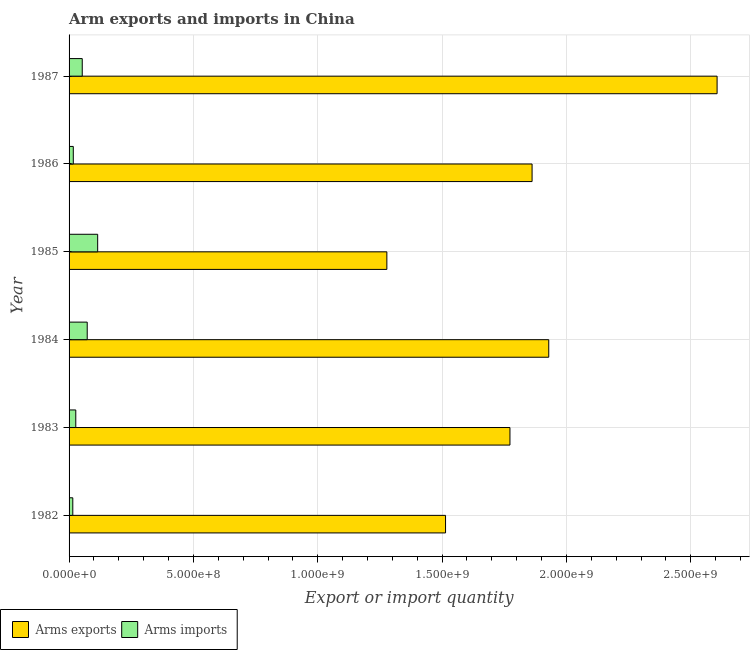Are the number of bars per tick equal to the number of legend labels?
Make the answer very short. Yes. How many bars are there on the 6th tick from the top?
Provide a short and direct response. 2. How many bars are there on the 6th tick from the bottom?
Keep it short and to the point. 2. What is the label of the 3rd group of bars from the top?
Ensure brevity in your answer.  1985. In how many cases, is the number of bars for a given year not equal to the number of legend labels?
Offer a terse response. 0. What is the arms imports in 1985?
Offer a very short reply. 1.15e+08. Across all years, what is the maximum arms imports?
Ensure brevity in your answer.  1.15e+08. Across all years, what is the minimum arms exports?
Give a very brief answer. 1.28e+09. In which year was the arms exports minimum?
Give a very brief answer. 1985. What is the total arms exports in the graph?
Offer a very short reply. 1.10e+1. What is the difference between the arms exports in 1983 and that in 1984?
Provide a succinct answer. -1.56e+08. What is the difference between the arms exports in 1987 and the arms imports in 1982?
Offer a very short reply. 2.59e+09. In the year 1986, what is the difference between the arms imports and arms exports?
Your answer should be compact. -1.84e+09. In how many years, is the arms exports greater than 1100000000 ?
Offer a terse response. 6. What is the ratio of the arms exports in 1982 to that in 1983?
Provide a short and direct response. 0.85. Is the arms exports in 1986 less than that in 1987?
Your answer should be very brief. Yes. What is the difference between the highest and the second highest arms imports?
Offer a very short reply. 4.20e+07. What is the difference between the highest and the lowest arms exports?
Your answer should be compact. 1.33e+09. In how many years, is the arms exports greater than the average arms exports taken over all years?
Ensure brevity in your answer.  3. Is the sum of the arms exports in 1984 and 1987 greater than the maximum arms imports across all years?
Your response must be concise. Yes. What does the 1st bar from the top in 1987 represents?
Make the answer very short. Arms imports. What does the 2nd bar from the bottom in 1984 represents?
Provide a succinct answer. Arms imports. How many bars are there?
Offer a terse response. 12. What is the difference between two consecutive major ticks on the X-axis?
Your answer should be compact. 5.00e+08. Where does the legend appear in the graph?
Offer a very short reply. Bottom left. How many legend labels are there?
Keep it short and to the point. 2. How are the legend labels stacked?
Offer a terse response. Horizontal. What is the title of the graph?
Your answer should be compact. Arm exports and imports in China. Does "Drinking water services" appear as one of the legend labels in the graph?
Offer a terse response. No. What is the label or title of the X-axis?
Give a very brief answer. Export or import quantity. What is the Export or import quantity of Arms exports in 1982?
Your answer should be compact. 1.51e+09. What is the Export or import quantity in Arms imports in 1982?
Provide a short and direct response. 1.50e+07. What is the Export or import quantity in Arms exports in 1983?
Your answer should be compact. 1.77e+09. What is the Export or import quantity in Arms imports in 1983?
Ensure brevity in your answer.  2.70e+07. What is the Export or import quantity in Arms exports in 1984?
Offer a terse response. 1.93e+09. What is the Export or import quantity of Arms imports in 1984?
Your response must be concise. 7.30e+07. What is the Export or import quantity in Arms exports in 1985?
Your answer should be compact. 1.28e+09. What is the Export or import quantity of Arms imports in 1985?
Provide a succinct answer. 1.15e+08. What is the Export or import quantity of Arms exports in 1986?
Offer a very short reply. 1.86e+09. What is the Export or import quantity of Arms imports in 1986?
Offer a very short reply. 1.70e+07. What is the Export or import quantity of Arms exports in 1987?
Provide a short and direct response. 2.61e+09. What is the Export or import quantity of Arms imports in 1987?
Your answer should be compact. 5.30e+07. Across all years, what is the maximum Export or import quantity of Arms exports?
Make the answer very short. 2.61e+09. Across all years, what is the maximum Export or import quantity in Arms imports?
Keep it short and to the point. 1.15e+08. Across all years, what is the minimum Export or import quantity in Arms exports?
Ensure brevity in your answer.  1.28e+09. Across all years, what is the minimum Export or import quantity of Arms imports?
Your answer should be compact. 1.50e+07. What is the total Export or import quantity in Arms exports in the graph?
Your response must be concise. 1.10e+1. What is the total Export or import quantity in Arms imports in the graph?
Offer a very short reply. 3.00e+08. What is the difference between the Export or import quantity of Arms exports in 1982 and that in 1983?
Your answer should be very brief. -2.59e+08. What is the difference between the Export or import quantity in Arms imports in 1982 and that in 1983?
Give a very brief answer. -1.20e+07. What is the difference between the Export or import quantity of Arms exports in 1982 and that in 1984?
Offer a terse response. -4.15e+08. What is the difference between the Export or import quantity in Arms imports in 1982 and that in 1984?
Offer a terse response. -5.80e+07. What is the difference between the Export or import quantity of Arms exports in 1982 and that in 1985?
Your answer should be compact. 2.36e+08. What is the difference between the Export or import quantity in Arms imports in 1982 and that in 1985?
Keep it short and to the point. -1.00e+08. What is the difference between the Export or import quantity in Arms exports in 1982 and that in 1986?
Your response must be concise. -3.48e+08. What is the difference between the Export or import quantity in Arms exports in 1982 and that in 1987?
Keep it short and to the point. -1.09e+09. What is the difference between the Export or import quantity of Arms imports in 1982 and that in 1987?
Give a very brief answer. -3.80e+07. What is the difference between the Export or import quantity of Arms exports in 1983 and that in 1984?
Ensure brevity in your answer.  -1.56e+08. What is the difference between the Export or import quantity in Arms imports in 1983 and that in 1984?
Offer a very short reply. -4.60e+07. What is the difference between the Export or import quantity in Arms exports in 1983 and that in 1985?
Provide a short and direct response. 4.95e+08. What is the difference between the Export or import quantity in Arms imports in 1983 and that in 1985?
Provide a short and direct response. -8.80e+07. What is the difference between the Export or import quantity of Arms exports in 1983 and that in 1986?
Offer a terse response. -8.90e+07. What is the difference between the Export or import quantity of Arms exports in 1983 and that in 1987?
Keep it short and to the point. -8.33e+08. What is the difference between the Export or import quantity in Arms imports in 1983 and that in 1987?
Your answer should be compact. -2.60e+07. What is the difference between the Export or import quantity in Arms exports in 1984 and that in 1985?
Your answer should be very brief. 6.51e+08. What is the difference between the Export or import quantity of Arms imports in 1984 and that in 1985?
Keep it short and to the point. -4.20e+07. What is the difference between the Export or import quantity of Arms exports in 1984 and that in 1986?
Offer a terse response. 6.70e+07. What is the difference between the Export or import quantity in Arms imports in 1984 and that in 1986?
Your answer should be compact. 5.60e+07. What is the difference between the Export or import quantity of Arms exports in 1984 and that in 1987?
Your answer should be very brief. -6.77e+08. What is the difference between the Export or import quantity in Arms imports in 1984 and that in 1987?
Keep it short and to the point. 2.00e+07. What is the difference between the Export or import quantity in Arms exports in 1985 and that in 1986?
Ensure brevity in your answer.  -5.84e+08. What is the difference between the Export or import quantity of Arms imports in 1985 and that in 1986?
Ensure brevity in your answer.  9.80e+07. What is the difference between the Export or import quantity of Arms exports in 1985 and that in 1987?
Offer a terse response. -1.33e+09. What is the difference between the Export or import quantity in Arms imports in 1985 and that in 1987?
Provide a succinct answer. 6.20e+07. What is the difference between the Export or import quantity in Arms exports in 1986 and that in 1987?
Offer a terse response. -7.44e+08. What is the difference between the Export or import quantity of Arms imports in 1986 and that in 1987?
Provide a short and direct response. -3.60e+07. What is the difference between the Export or import quantity of Arms exports in 1982 and the Export or import quantity of Arms imports in 1983?
Provide a short and direct response. 1.49e+09. What is the difference between the Export or import quantity in Arms exports in 1982 and the Export or import quantity in Arms imports in 1984?
Provide a succinct answer. 1.44e+09. What is the difference between the Export or import quantity in Arms exports in 1982 and the Export or import quantity in Arms imports in 1985?
Make the answer very short. 1.40e+09. What is the difference between the Export or import quantity of Arms exports in 1982 and the Export or import quantity of Arms imports in 1986?
Offer a terse response. 1.50e+09. What is the difference between the Export or import quantity of Arms exports in 1982 and the Export or import quantity of Arms imports in 1987?
Your response must be concise. 1.46e+09. What is the difference between the Export or import quantity in Arms exports in 1983 and the Export or import quantity in Arms imports in 1984?
Keep it short and to the point. 1.70e+09. What is the difference between the Export or import quantity in Arms exports in 1983 and the Export or import quantity in Arms imports in 1985?
Ensure brevity in your answer.  1.66e+09. What is the difference between the Export or import quantity in Arms exports in 1983 and the Export or import quantity in Arms imports in 1986?
Your answer should be compact. 1.76e+09. What is the difference between the Export or import quantity in Arms exports in 1983 and the Export or import quantity in Arms imports in 1987?
Give a very brief answer. 1.72e+09. What is the difference between the Export or import quantity in Arms exports in 1984 and the Export or import quantity in Arms imports in 1985?
Your answer should be very brief. 1.81e+09. What is the difference between the Export or import quantity in Arms exports in 1984 and the Export or import quantity in Arms imports in 1986?
Provide a short and direct response. 1.91e+09. What is the difference between the Export or import quantity of Arms exports in 1984 and the Export or import quantity of Arms imports in 1987?
Provide a succinct answer. 1.88e+09. What is the difference between the Export or import quantity of Arms exports in 1985 and the Export or import quantity of Arms imports in 1986?
Offer a terse response. 1.26e+09. What is the difference between the Export or import quantity in Arms exports in 1985 and the Export or import quantity in Arms imports in 1987?
Provide a succinct answer. 1.22e+09. What is the difference between the Export or import quantity in Arms exports in 1986 and the Export or import quantity in Arms imports in 1987?
Offer a terse response. 1.81e+09. What is the average Export or import quantity of Arms exports per year?
Keep it short and to the point. 1.83e+09. What is the average Export or import quantity in Arms imports per year?
Your response must be concise. 5.00e+07. In the year 1982, what is the difference between the Export or import quantity in Arms exports and Export or import quantity in Arms imports?
Offer a very short reply. 1.50e+09. In the year 1983, what is the difference between the Export or import quantity in Arms exports and Export or import quantity in Arms imports?
Keep it short and to the point. 1.75e+09. In the year 1984, what is the difference between the Export or import quantity in Arms exports and Export or import quantity in Arms imports?
Your response must be concise. 1.86e+09. In the year 1985, what is the difference between the Export or import quantity of Arms exports and Export or import quantity of Arms imports?
Give a very brief answer. 1.16e+09. In the year 1986, what is the difference between the Export or import quantity in Arms exports and Export or import quantity in Arms imports?
Offer a terse response. 1.84e+09. In the year 1987, what is the difference between the Export or import quantity in Arms exports and Export or import quantity in Arms imports?
Offer a terse response. 2.55e+09. What is the ratio of the Export or import quantity in Arms exports in 1982 to that in 1983?
Offer a terse response. 0.85. What is the ratio of the Export or import quantity of Arms imports in 1982 to that in 1983?
Your answer should be compact. 0.56. What is the ratio of the Export or import quantity of Arms exports in 1982 to that in 1984?
Your response must be concise. 0.78. What is the ratio of the Export or import quantity of Arms imports in 1982 to that in 1984?
Provide a short and direct response. 0.21. What is the ratio of the Export or import quantity of Arms exports in 1982 to that in 1985?
Offer a terse response. 1.18. What is the ratio of the Export or import quantity in Arms imports in 1982 to that in 1985?
Your response must be concise. 0.13. What is the ratio of the Export or import quantity in Arms exports in 1982 to that in 1986?
Ensure brevity in your answer.  0.81. What is the ratio of the Export or import quantity in Arms imports in 1982 to that in 1986?
Your answer should be compact. 0.88. What is the ratio of the Export or import quantity in Arms exports in 1982 to that in 1987?
Give a very brief answer. 0.58. What is the ratio of the Export or import quantity in Arms imports in 1982 to that in 1987?
Offer a terse response. 0.28. What is the ratio of the Export or import quantity in Arms exports in 1983 to that in 1984?
Provide a short and direct response. 0.92. What is the ratio of the Export or import quantity of Arms imports in 1983 to that in 1984?
Keep it short and to the point. 0.37. What is the ratio of the Export or import quantity of Arms exports in 1983 to that in 1985?
Make the answer very short. 1.39. What is the ratio of the Export or import quantity of Arms imports in 1983 to that in 1985?
Your response must be concise. 0.23. What is the ratio of the Export or import quantity of Arms exports in 1983 to that in 1986?
Provide a short and direct response. 0.95. What is the ratio of the Export or import quantity in Arms imports in 1983 to that in 1986?
Offer a terse response. 1.59. What is the ratio of the Export or import quantity in Arms exports in 1983 to that in 1987?
Provide a short and direct response. 0.68. What is the ratio of the Export or import quantity in Arms imports in 1983 to that in 1987?
Your answer should be very brief. 0.51. What is the ratio of the Export or import quantity of Arms exports in 1984 to that in 1985?
Keep it short and to the point. 1.51. What is the ratio of the Export or import quantity of Arms imports in 1984 to that in 1985?
Your response must be concise. 0.63. What is the ratio of the Export or import quantity in Arms exports in 1984 to that in 1986?
Keep it short and to the point. 1.04. What is the ratio of the Export or import quantity of Arms imports in 1984 to that in 1986?
Offer a terse response. 4.29. What is the ratio of the Export or import quantity in Arms exports in 1984 to that in 1987?
Your answer should be compact. 0.74. What is the ratio of the Export or import quantity of Arms imports in 1984 to that in 1987?
Ensure brevity in your answer.  1.38. What is the ratio of the Export or import quantity in Arms exports in 1985 to that in 1986?
Offer a very short reply. 0.69. What is the ratio of the Export or import quantity in Arms imports in 1985 to that in 1986?
Provide a short and direct response. 6.76. What is the ratio of the Export or import quantity in Arms exports in 1985 to that in 1987?
Provide a short and direct response. 0.49. What is the ratio of the Export or import quantity of Arms imports in 1985 to that in 1987?
Your answer should be very brief. 2.17. What is the ratio of the Export or import quantity of Arms exports in 1986 to that in 1987?
Your answer should be very brief. 0.71. What is the ratio of the Export or import quantity in Arms imports in 1986 to that in 1987?
Offer a terse response. 0.32. What is the difference between the highest and the second highest Export or import quantity of Arms exports?
Offer a terse response. 6.77e+08. What is the difference between the highest and the second highest Export or import quantity in Arms imports?
Your answer should be very brief. 4.20e+07. What is the difference between the highest and the lowest Export or import quantity in Arms exports?
Offer a very short reply. 1.33e+09. What is the difference between the highest and the lowest Export or import quantity in Arms imports?
Make the answer very short. 1.00e+08. 